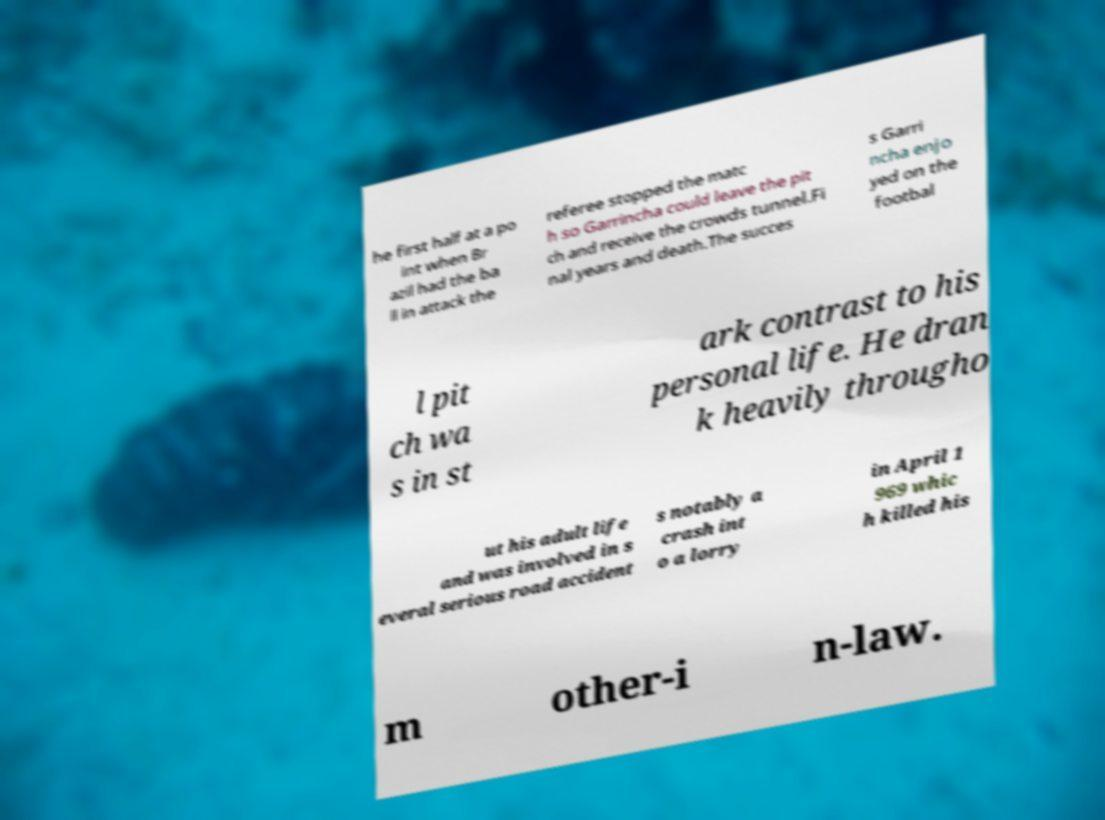Please read and relay the text visible in this image. What does it say? he first half at a po int when Br azil had the ba ll in attack the referee stopped the matc h so Garrincha could leave the pit ch and receive the crowds tunnel.Fi nal years and death.The succes s Garri ncha enjo yed on the footbal l pit ch wa s in st ark contrast to his personal life. He dran k heavily througho ut his adult life and was involved in s everal serious road accident s notably a crash int o a lorry in April 1 969 whic h killed his m other-i n-law. 